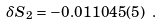Convert formula to latex. <formula><loc_0><loc_0><loc_500><loc_500>\delta S _ { 2 } = - 0 . 0 1 1 0 4 5 ( 5 ) \ .</formula> 